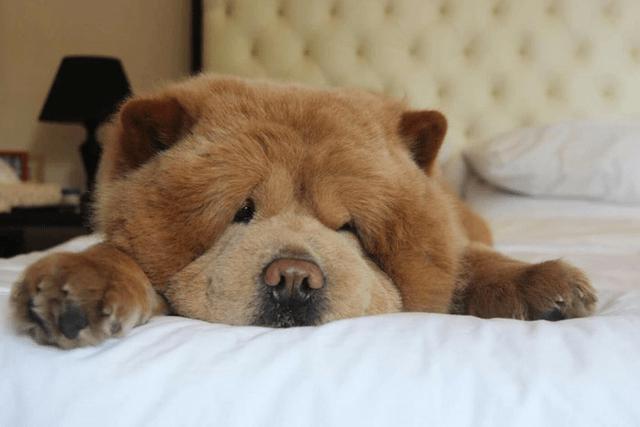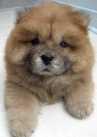The first image is the image on the left, the second image is the image on the right. For the images displayed, is the sentence "The right image contains at least two chow dogs." factually correct? Answer yes or no. No. The first image is the image on the left, the second image is the image on the right. Examine the images to the left and right. Is the description "There are at most two dogs." accurate? Answer yes or no. Yes. 